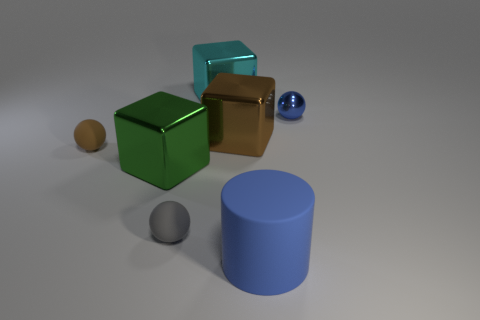Subtract all rubber spheres. How many spheres are left? 1 Add 3 big yellow metallic objects. How many objects exist? 10 Subtract all cyan cubes. How many cubes are left? 2 Subtract all spheres. How many objects are left? 4 Add 6 large shiny blocks. How many large shiny blocks exist? 9 Subtract 0 gray cylinders. How many objects are left? 7 Subtract 1 cylinders. How many cylinders are left? 0 Subtract all brown cylinders. Subtract all green blocks. How many cylinders are left? 1 Subtract all cyan cubes. Subtract all large objects. How many objects are left? 2 Add 5 big cylinders. How many big cylinders are left? 6 